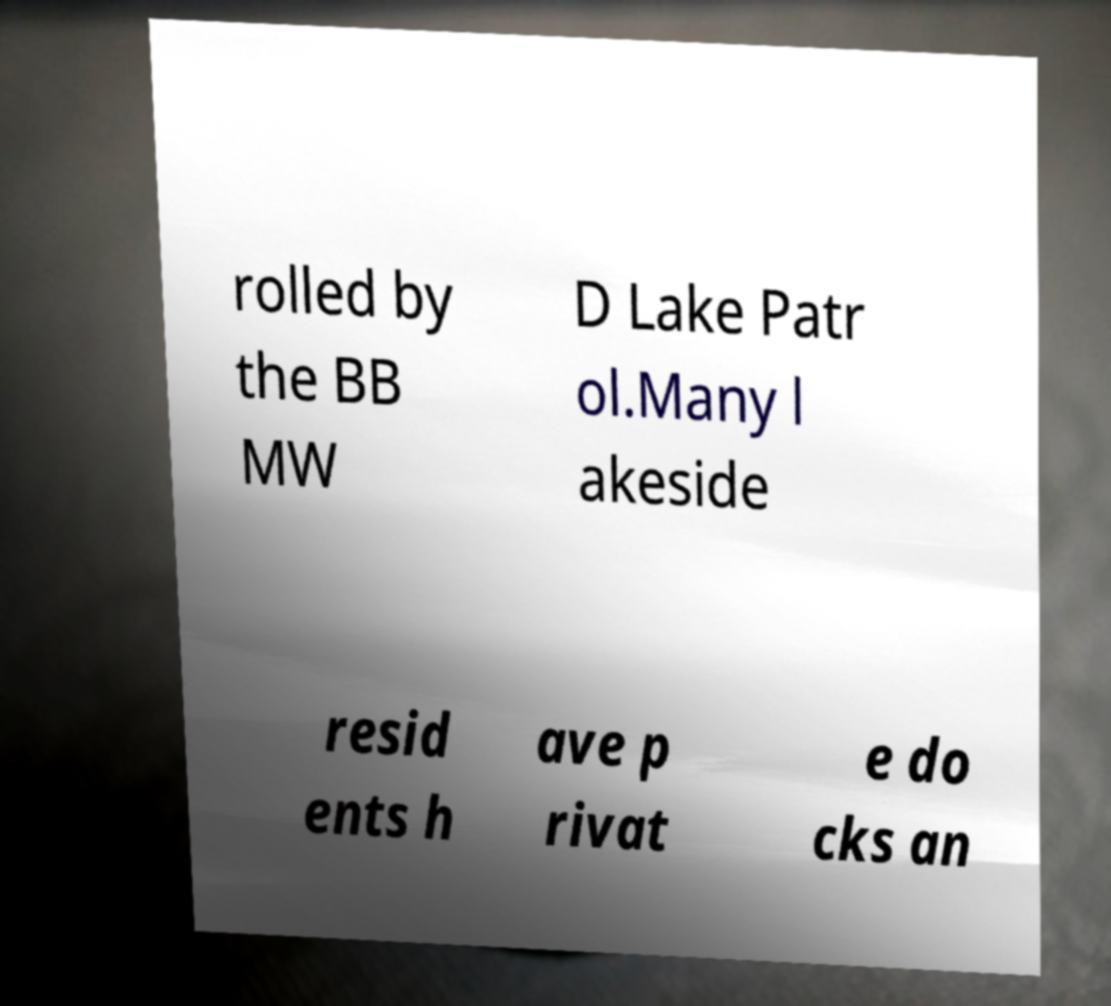Can you read and provide the text displayed in the image?This photo seems to have some interesting text. Can you extract and type it out for me? rolled by the BB MW D Lake Patr ol.Many l akeside resid ents h ave p rivat e do cks an 